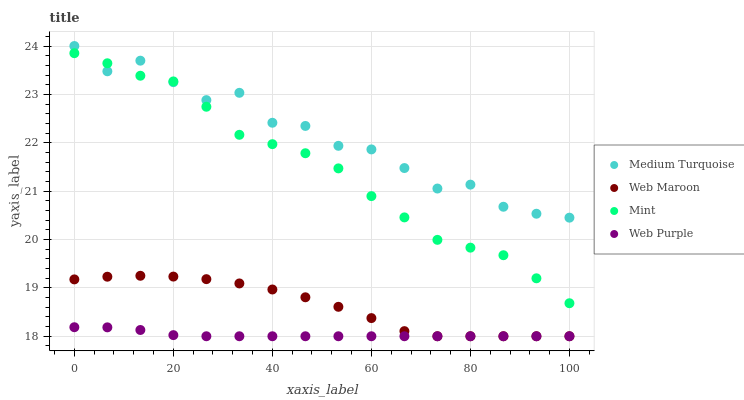Does Web Purple have the minimum area under the curve?
Answer yes or no. Yes. Does Medium Turquoise have the maximum area under the curve?
Answer yes or no. Yes. Does Web Maroon have the minimum area under the curve?
Answer yes or no. No. Does Web Maroon have the maximum area under the curve?
Answer yes or no. No. Is Web Purple the smoothest?
Answer yes or no. Yes. Is Medium Turquoise the roughest?
Answer yes or no. Yes. Is Web Maroon the smoothest?
Answer yes or no. No. Is Web Maroon the roughest?
Answer yes or no. No. Does Web Purple have the lowest value?
Answer yes or no. Yes. Does Medium Turquoise have the lowest value?
Answer yes or no. No. Does Medium Turquoise have the highest value?
Answer yes or no. Yes. Does Web Maroon have the highest value?
Answer yes or no. No. Is Web Purple less than Medium Turquoise?
Answer yes or no. Yes. Is Medium Turquoise greater than Web Maroon?
Answer yes or no. Yes. Does Medium Turquoise intersect Mint?
Answer yes or no. Yes. Is Medium Turquoise less than Mint?
Answer yes or no. No. Is Medium Turquoise greater than Mint?
Answer yes or no. No. Does Web Purple intersect Medium Turquoise?
Answer yes or no. No. 